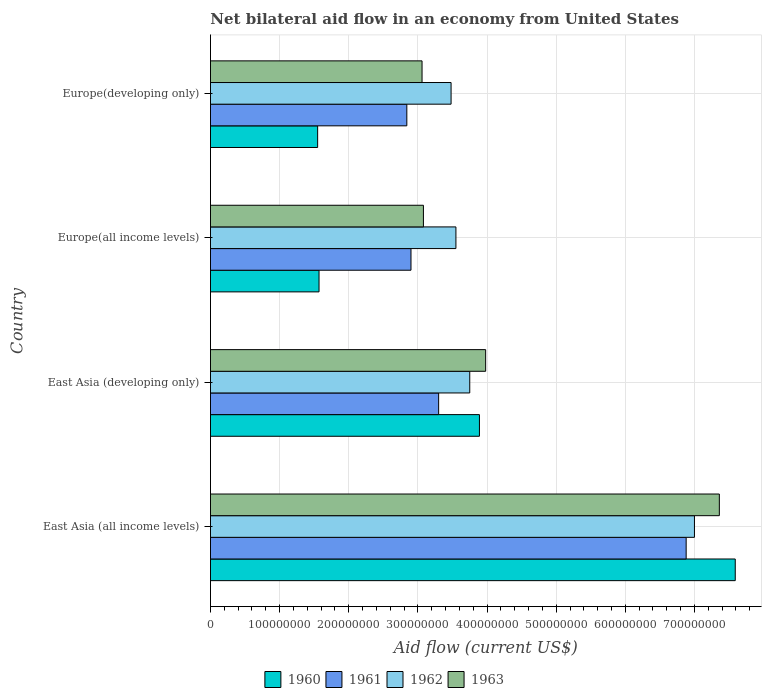How many different coloured bars are there?
Provide a short and direct response. 4. How many groups of bars are there?
Your answer should be compact. 4. Are the number of bars on each tick of the Y-axis equal?
Give a very brief answer. Yes. How many bars are there on the 3rd tick from the bottom?
Your answer should be compact. 4. What is the label of the 1st group of bars from the top?
Keep it short and to the point. Europe(developing only). What is the net bilateral aid flow in 1960 in East Asia (all income levels)?
Offer a very short reply. 7.59e+08. Across all countries, what is the maximum net bilateral aid flow in 1961?
Your answer should be compact. 6.88e+08. Across all countries, what is the minimum net bilateral aid flow in 1960?
Your answer should be compact. 1.55e+08. In which country was the net bilateral aid flow in 1960 maximum?
Your answer should be very brief. East Asia (all income levels). In which country was the net bilateral aid flow in 1963 minimum?
Your answer should be compact. Europe(developing only). What is the total net bilateral aid flow in 1963 in the graph?
Keep it short and to the point. 1.75e+09. What is the difference between the net bilateral aid flow in 1963 in Europe(developing only) and the net bilateral aid flow in 1962 in East Asia (developing only)?
Your answer should be compact. -6.90e+07. What is the average net bilateral aid flow in 1961 per country?
Provide a succinct answer. 3.98e+08. What is the difference between the net bilateral aid flow in 1963 and net bilateral aid flow in 1962 in East Asia (developing only)?
Provide a succinct answer. 2.30e+07. In how many countries, is the net bilateral aid flow in 1962 greater than 200000000 US$?
Your answer should be compact. 4. What is the ratio of the net bilateral aid flow in 1961 in East Asia (all income levels) to that in Europe(developing only)?
Give a very brief answer. 2.42. What is the difference between the highest and the second highest net bilateral aid flow in 1961?
Make the answer very short. 3.58e+08. What is the difference between the highest and the lowest net bilateral aid flow in 1963?
Offer a very short reply. 4.30e+08. In how many countries, is the net bilateral aid flow in 1961 greater than the average net bilateral aid flow in 1961 taken over all countries?
Provide a succinct answer. 1. How many bars are there?
Offer a terse response. 16. What is the difference between two consecutive major ticks on the X-axis?
Your answer should be compact. 1.00e+08. Are the values on the major ticks of X-axis written in scientific E-notation?
Offer a very short reply. No. Does the graph contain grids?
Give a very brief answer. Yes. What is the title of the graph?
Keep it short and to the point. Net bilateral aid flow in an economy from United States. What is the label or title of the X-axis?
Keep it short and to the point. Aid flow (current US$). What is the label or title of the Y-axis?
Your answer should be compact. Country. What is the Aid flow (current US$) of 1960 in East Asia (all income levels)?
Your answer should be very brief. 7.59e+08. What is the Aid flow (current US$) in 1961 in East Asia (all income levels)?
Keep it short and to the point. 6.88e+08. What is the Aid flow (current US$) of 1962 in East Asia (all income levels)?
Make the answer very short. 7.00e+08. What is the Aid flow (current US$) of 1963 in East Asia (all income levels)?
Your answer should be very brief. 7.36e+08. What is the Aid flow (current US$) of 1960 in East Asia (developing only)?
Your answer should be very brief. 3.89e+08. What is the Aid flow (current US$) of 1961 in East Asia (developing only)?
Ensure brevity in your answer.  3.30e+08. What is the Aid flow (current US$) in 1962 in East Asia (developing only)?
Provide a short and direct response. 3.75e+08. What is the Aid flow (current US$) in 1963 in East Asia (developing only)?
Give a very brief answer. 3.98e+08. What is the Aid flow (current US$) of 1960 in Europe(all income levels)?
Ensure brevity in your answer.  1.57e+08. What is the Aid flow (current US$) in 1961 in Europe(all income levels)?
Your answer should be very brief. 2.90e+08. What is the Aid flow (current US$) of 1962 in Europe(all income levels)?
Keep it short and to the point. 3.55e+08. What is the Aid flow (current US$) of 1963 in Europe(all income levels)?
Provide a succinct answer. 3.08e+08. What is the Aid flow (current US$) of 1960 in Europe(developing only)?
Offer a very short reply. 1.55e+08. What is the Aid flow (current US$) in 1961 in Europe(developing only)?
Your answer should be compact. 2.84e+08. What is the Aid flow (current US$) in 1962 in Europe(developing only)?
Offer a very short reply. 3.48e+08. What is the Aid flow (current US$) of 1963 in Europe(developing only)?
Offer a terse response. 3.06e+08. Across all countries, what is the maximum Aid flow (current US$) of 1960?
Your answer should be very brief. 7.59e+08. Across all countries, what is the maximum Aid flow (current US$) of 1961?
Make the answer very short. 6.88e+08. Across all countries, what is the maximum Aid flow (current US$) of 1962?
Offer a very short reply. 7.00e+08. Across all countries, what is the maximum Aid flow (current US$) of 1963?
Ensure brevity in your answer.  7.36e+08. Across all countries, what is the minimum Aid flow (current US$) of 1960?
Your response must be concise. 1.55e+08. Across all countries, what is the minimum Aid flow (current US$) in 1961?
Your answer should be very brief. 2.84e+08. Across all countries, what is the minimum Aid flow (current US$) in 1962?
Your response must be concise. 3.48e+08. Across all countries, what is the minimum Aid flow (current US$) of 1963?
Give a very brief answer. 3.06e+08. What is the total Aid flow (current US$) of 1960 in the graph?
Your response must be concise. 1.46e+09. What is the total Aid flow (current US$) in 1961 in the graph?
Provide a short and direct response. 1.59e+09. What is the total Aid flow (current US$) of 1962 in the graph?
Offer a very short reply. 1.78e+09. What is the total Aid flow (current US$) of 1963 in the graph?
Your answer should be compact. 1.75e+09. What is the difference between the Aid flow (current US$) of 1960 in East Asia (all income levels) and that in East Asia (developing only)?
Your response must be concise. 3.70e+08. What is the difference between the Aid flow (current US$) in 1961 in East Asia (all income levels) and that in East Asia (developing only)?
Ensure brevity in your answer.  3.58e+08. What is the difference between the Aid flow (current US$) in 1962 in East Asia (all income levels) and that in East Asia (developing only)?
Offer a very short reply. 3.25e+08. What is the difference between the Aid flow (current US$) in 1963 in East Asia (all income levels) and that in East Asia (developing only)?
Offer a very short reply. 3.38e+08. What is the difference between the Aid flow (current US$) in 1960 in East Asia (all income levels) and that in Europe(all income levels)?
Provide a succinct answer. 6.02e+08. What is the difference between the Aid flow (current US$) of 1961 in East Asia (all income levels) and that in Europe(all income levels)?
Give a very brief answer. 3.98e+08. What is the difference between the Aid flow (current US$) in 1962 in East Asia (all income levels) and that in Europe(all income levels)?
Your answer should be very brief. 3.45e+08. What is the difference between the Aid flow (current US$) of 1963 in East Asia (all income levels) and that in Europe(all income levels)?
Give a very brief answer. 4.28e+08. What is the difference between the Aid flow (current US$) in 1960 in East Asia (all income levels) and that in Europe(developing only)?
Offer a terse response. 6.04e+08. What is the difference between the Aid flow (current US$) of 1961 in East Asia (all income levels) and that in Europe(developing only)?
Make the answer very short. 4.04e+08. What is the difference between the Aid flow (current US$) of 1962 in East Asia (all income levels) and that in Europe(developing only)?
Your answer should be compact. 3.52e+08. What is the difference between the Aid flow (current US$) in 1963 in East Asia (all income levels) and that in Europe(developing only)?
Give a very brief answer. 4.30e+08. What is the difference between the Aid flow (current US$) in 1960 in East Asia (developing only) and that in Europe(all income levels)?
Keep it short and to the point. 2.32e+08. What is the difference between the Aid flow (current US$) in 1961 in East Asia (developing only) and that in Europe(all income levels)?
Offer a terse response. 4.00e+07. What is the difference between the Aid flow (current US$) in 1962 in East Asia (developing only) and that in Europe(all income levels)?
Provide a short and direct response. 2.00e+07. What is the difference between the Aid flow (current US$) in 1963 in East Asia (developing only) and that in Europe(all income levels)?
Keep it short and to the point. 9.00e+07. What is the difference between the Aid flow (current US$) of 1960 in East Asia (developing only) and that in Europe(developing only)?
Provide a short and direct response. 2.34e+08. What is the difference between the Aid flow (current US$) in 1961 in East Asia (developing only) and that in Europe(developing only)?
Your answer should be very brief. 4.60e+07. What is the difference between the Aid flow (current US$) of 1962 in East Asia (developing only) and that in Europe(developing only)?
Give a very brief answer. 2.70e+07. What is the difference between the Aid flow (current US$) in 1963 in East Asia (developing only) and that in Europe(developing only)?
Give a very brief answer. 9.20e+07. What is the difference between the Aid flow (current US$) of 1961 in Europe(all income levels) and that in Europe(developing only)?
Your answer should be very brief. 6.00e+06. What is the difference between the Aid flow (current US$) in 1962 in Europe(all income levels) and that in Europe(developing only)?
Make the answer very short. 7.00e+06. What is the difference between the Aid flow (current US$) in 1960 in East Asia (all income levels) and the Aid flow (current US$) in 1961 in East Asia (developing only)?
Ensure brevity in your answer.  4.29e+08. What is the difference between the Aid flow (current US$) of 1960 in East Asia (all income levels) and the Aid flow (current US$) of 1962 in East Asia (developing only)?
Keep it short and to the point. 3.84e+08. What is the difference between the Aid flow (current US$) in 1960 in East Asia (all income levels) and the Aid flow (current US$) in 1963 in East Asia (developing only)?
Your answer should be compact. 3.61e+08. What is the difference between the Aid flow (current US$) of 1961 in East Asia (all income levels) and the Aid flow (current US$) of 1962 in East Asia (developing only)?
Make the answer very short. 3.13e+08. What is the difference between the Aid flow (current US$) in 1961 in East Asia (all income levels) and the Aid flow (current US$) in 1963 in East Asia (developing only)?
Offer a very short reply. 2.90e+08. What is the difference between the Aid flow (current US$) in 1962 in East Asia (all income levels) and the Aid flow (current US$) in 1963 in East Asia (developing only)?
Ensure brevity in your answer.  3.02e+08. What is the difference between the Aid flow (current US$) of 1960 in East Asia (all income levels) and the Aid flow (current US$) of 1961 in Europe(all income levels)?
Offer a very short reply. 4.69e+08. What is the difference between the Aid flow (current US$) in 1960 in East Asia (all income levels) and the Aid flow (current US$) in 1962 in Europe(all income levels)?
Offer a terse response. 4.04e+08. What is the difference between the Aid flow (current US$) in 1960 in East Asia (all income levels) and the Aid flow (current US$) in 1963 in Europe(all income levels)?
Give a very brief answer. 4.51e+08. What is the difference between the Aid flow (current US$) of 1961 in East Asia (all income levels) and the Aid flow (current US$) of 1962 in Europe(all income levels)?
Provide a succinct answer. 3.33e+08. What is the difference between the Aid flow (current US$) of 1961 in East Asia (all income levels) and the Aid flow (current US$) of 1963 in Europe(all income levels)?
Give a very brief answer. 3.80e+08. What is the difference between the Aid flow (current US$) of 1962 in East Asia (all income levels) and the Aid flow (current US$) of 1963 in Europe(all income levels)?
Offer a terse response. 3.92e+08. What is the difference between the Aid flow (current US$) of 1960 in East Asia (all income levels) and the Aid flow (current US$) of 1961 in Europe(developing only)?
Make the answer very short. 4.75e+08. What is the difference between the Aid flow (current US$) of 1960 in East Asia (all income levels) and the Aid flow (current US$) of 1962 in Europe(developing only)?
Give a very brief answer. 4.11e+08. What is the difference between the Aid flow (current US$) in 1960 in East Asia (all income levels) and the Aid flow (current US$) in 1963 in Europe(developing only)?
Your answer should be compact. 4.53e+08. What is the difference between the Aid flow (current US$) of 1961 in East Asia (all income levels) and the Aid flow (current US$) of 1962 in Europe(developing only)?
Keep it short and to the point. 3.40e+08. What is the difference between the Aid flow (current US$) of 1961 in East Asia (all income levels) and the Aid flow (current US$) of 1963 in Europe(developing only)?
Make the answer very short. 3.82e+08. What is the difference between the Aid flow (current US$) in 1962 in East Asia (all income levels) and the Aid flow (current US$) in 1963 in Europe(developing only)?
Your answer should be very brief. 3.94e+08. What is the difference between the Aid flow (current US$) in 1960 in East Asia (developing only) and the Aid flow (current US$) in 1961 in Europe(all income levels)?
Your response must be concise. 9.90e+07. What is the difference between the Aid flow (current US$) in 1960 in East Asia (developing only) and the Aid flow (current US$) in 1962 in Europe(all income levels)?
Offer a very short reply. 3.40e+07. What is the difference between the Aid flow (current US$) of 1960 in East Asia (developing only) and the Aid flow (current US$) of 1963 in Europe(all income levels)?
Give a very brief answer. 8.10e+07. What is the difference between the Aid flow (current US$) of 1961 in East Asia (developing only) and the Aid flow (current US$) of 1962 in Europe(all income levels)?
Your answer should be very brief. -2.50e+07. What is the difference between the Aid flow (current US$) of 1961 in East Asia (developing only) and the Aid flow (current US$) of 1963 in Europe(all income levels)?
Your answer should be compact. 2.20e+07. What is the difference between the Aid flow (current US$) of 1962 in East Asia (developing only) and the Aid flow (current US$) of 1963 in Europe(all income levels)?
Make the answer very short. 6.70e+07. What is the difference between the Aid flow (current US$) of 1960 in East Asia (developing only) and the Aid flow (current US$) of 1961 in Europe(developing only)?
Your response must be concise. 1.05e+08. What is the difference between the Aid flow (current US$) in 1960 in East Asia (developing only) and the Aid flow (current US$) in 1962 in Europe(developing only)?
Keep it short and to the point. 4.10e+07. What is the difference between the Aid flow (current US$) in 1960 in East Asia (developing only) and the Aid flow (current US$) in 1963 in Europe(developing only)?
Offer a terse response. 8.30e+07. What is the difference between the Aid flow (current US$) of 1961 in East Asia (developing only) and the Aid flow (current US$) of 1962 in Europe(developing only)?
Ensure brevity in your answer.  -1.80e+07. What is the difference between the Aid flow (current US$) of 1961 in East Asia (developing only) and the Aid flow (current US$) of 1963 in Europe(developing only)?
Give a very brief answer. 2.40e+07. What is the difference between the Aid flow (current US$) in 1962 in East Asia (developing only) and the Aid flow (current US$) in 1963 in Europe(developing only)?
Your answer should be compact. 6.90e+07. What is the difference between the Aid flow (current US$) of 1960 in Europe(all income levels) and the Aid flow (current US$) of 1961 in Europe(developing only)?
Your answer should be very brief. -1.27e+08. What is the difference between the Aid flow (current US$) in 1960 in Europe(all income levels) and the Aid flow (current US$) in 1962 in Europe(developing only)?
Provide a succinct answer. -1.91e+08. What is the difference between the Aid flow (current US$) in 1960 in Europe(all income levels) and the Aid flow (current US$) in 1963 in Europe(developing only)?
Make the answer very short. -1.49e+08. What is the difference between the Aid flow (current US$) of 1961 in Europe(all income levels) and the Aid flow (current US$) of 1962 in Europe(developing only)?
Provide a short and direct response. -5.80e+07. What is the difference between the Aid flow (current US$) in 1961 in Europe(all income levels) and the Aid flow (current US$) in 1963 in Europe(developing only)?
Provide a succinct answer. -1.60e+07. What is the difference between the Aid flow (current US$) in 1962 in Europe(all income levels) and the Aid flow (current US$) in 1963 in Europe(developing only)?
Your answer should be very brief. 4.90e+07. What is the average Aid flow (current US$) of 1960 per country?
Ensure brevity in your answer.  3.65e+08. What is the average Aid flow (current US$) of 1961 per country?
Provide a short and direct response. 3.98e+08. What is the average Aid flow (current US$) of 1962 per country?
Keep it short and to the point. 4.44e+08. What is the average Aid flow (current US$) of 1963 per country?
Make the answer very short. 4.37e+08. What is the difference between the Aid flow (current US$) in 1960 and Aid flow (current US$) in 1961 in East Asia (all income levels)?
Make the answer very short. 7.10e+07. What is the difference between the Aid flow (current US$) in 1960 and Aid flow (current US$) in 1962 in East Asia (all income levels)?
Provide a short and direct response. 5.90e+07. What is the difference between the Aid flow (current US$) of 1960 and Aid flow (current US$) of 1963 in East Asia (all income levels)?
Make the answer very short. 2.30e+07. What is the difference between the Aid flow (current US$) in 1961 and Aid flow (current US$) in 1962 in East Asia (all income levels)?
Offer a terse response. -1.20e+07. What is the difference between the Aid flow (current US$) of 1961 and Aid flow (current US$) of 1963 in East Asia (all income levels)?
Your answer should be compact. -4.80e+07. What is the difference between the Aid flow (current US$) in 1962 and Aid flow (current US$) in 1963 in East Asia (all income levels)?
Your answer should be very brief. -3.60e+07. What is the difference between the Aid flow (current US$) in 1960 and Aid flow (current US$) in 1961 in East Asia (developing only)?
Give a very brief answer. 5.90e+07. What is the difference between the Aid flow (current US$) in 1960 and Aid flow (current US$) in 1962 in East Asia (developing only)?
Make the answer very short. 1.40e+07. What is the difference between the Aid flow (current US$) in 1960 and Aid flow (current US$) in 1963 in East Asia (developing only)?
Keep it short and to the point. -9.00e+06. What is the difference between the Aid flow (current US$) of 1961 and Aid flow (current US$) of 1962 in East Asia (developing only)?
Ensure brevity in your answer.  -4.50e+07. What is the difference between the Aid flow (current US$) in 1961 and Aid flow (current US$) in 1963 in East Asia (developing only)?
Your response must be concise. -6.80e+07. What is the difference between the Aid flow (current US$) of 1962 and Aid flow (current US$) of 1963 in East Asia (developing only)?
Your response must be concise. -2.30e+07. What is the difference between the Aid flow (current US$) in 1960 and Aid flow (current US$) in 1961 in Europe(all income levels)?
Offer a very short reply. -1.33e+08. What is the difference between the Aid flow (current US$) in 1960 and Aid flow (current US$) in 1962 in Europe(all income levels)?
Provide a short and direct response. -1.98e+08. What is the difference between the Aid flow (current US$) in 1960 and Aid flow (current US$) in 1963 in Europe(all income levels)?
Make the answer very short. -1.51e+08. What is the difference between the Aid flow (current US$) of 1961 and Aid flow (current US$) of 1962 in Europe(all income levels)?
Offer a very short reply. -6.50e+07. What is the difference between the Aid flow (current US$) in 1961 and Aid flow (current US$) in 1963 in Europe(all income levels)?
Ensure brevity in your answer.  -1.80e+07. What is the difference between the Aid flow (current US$) in 1962 and Aid flow (current US$) in 1963 in Europe(all income levels)?
Provide a succinct answer. 4.70e+07. What is the difference between the Aid flow (current US$) of 1960 and Aid flow (current US$) of 1961 in Europe(developing only)?
Keep it short and to the point. -1.29e+08. What is the difference between the Aid flow (current US$) in 1960 and Aid flow (current US$) in 1962 in Europe(developing only)?
Offer a very short reply. -1.93e+08. What is the difference between the Aid flow (current US$) in 1960 and Aid flow (current US$) in 1963 in Europe(developing only)?
Keep it short and to the point. -1.51e+08. What is the difference between the Aid flow (current US$) in 1961 and Aid flow (current US$) in 1962 in Europe(developing only)?
Provide a succinct answer. -6.40e+07. What is the difference between the Aid flow (current US$) in 1961 and Aid flow (current US$) in 1963 in Europe(developing only)?
Make the answer very short. -2.20e+07. What is the difference between the Aid flow (current US$) of 1962 and Aid flow (current US$) of 1963 in Europe(developing only)?
Offer a very short reply. 4.20e+07. What is the ratio of the Aid flow (current US$) in 1960 in East Asia (all income levels) to that in East Asia (developing only)?
Offer a terse response. 1.95. What is the ratio of the Aid flow (current US$) in 1961 in East Asia (all income levels) to that in East Asia (developing only)?
Your response must be concise. 2.08. What is the ratio of the Aid flow (current US$) of 1962 in East Asia (all income levels) to that in East Asia (developing only)?
Offer a very short reply. 1.87. What is the ratio of the Aid flow (current US$) in 1963 in East Asia (all income levels) to that in East Asia (developing only)?
Offer a terse response. 1.85. What is the ratio of the Aid flow (current US$) of 1960 in East Asia (all income levels) to that in Europe(all income levels)?
Offer a terse response. 4.83. What is the ratio of the Aid flow (current US$) of 1961 in East Asia (all income levels) to that in Europe(all income levels)?
Your response must be concise. 2.37. What is the ratio of the Aid flow (current US$) of 1962 in East Asia (all income levels) to that in Europe(all income levels)?
Provide a short and direct response. 1.97. What is the ratio of the Aid flow (current US$) of 1963 in East Asia (all income levels) to that in Europe(all income levels)?
Ensure brevity in your answer.  2.39. What is the ratio of the Aid flow (current US$) of 1960 in East Asia (all income levels) to that in Europe(developing only)?
Keep it short and to the point. 4.9. What is the ratio of the Aid flow (current US$) of 1961 in East Asia (all income levels) to that in Europe(developing only)?
Your answer should be very brief. 2.42. What is the ratio of the Aid flow (current US$) in 1962 in East Asia (all income levels) to that in Europe(developing only)?
Ensure brevity in your answer.  2.01. What is the ratio of the Aid flow (current US$) of 1963 in East Asia (all income levels) to that in Europe(developing only)?
Make the answer very short. 2.41. What is the ratio of the Aid flow (current US$) in 1960 in East Asia (developing only) to that in Europe(all income levels)?
Make the answer very short. 2.48. What is the ratio of the Aid flow (current US$) of 1961 in East Asia (developing only) to that in Europe(all income levels)?
Offer a terse response. 1.14. What is the ratio of the Aid flow (current US$) of 1962 in East Asia (developing only) to that in Europe(all income levels)?
Offer a very short reply. 1.06. What is the ratio of the Aid flow (current US$) of 1963 in East Asia (developing only) to that in Europe(all income levels)?
Offer a terse response. 1.29. What is the ratio of the Aid flow (current US$) of 1960 in East Asia (developing only) to that in Europe(developing only)?
Give a very brief answer. 2.51. What is the ratio of the Aid flow (current US$) in 1961 in East Asia (developing only) to that in Europe(developing only)?
Provide a succinct answer. 1.16. What is the ratio of the Aid flow (current US$) in 1962 in East Asia (developing only) to that in Europe(developing only)?
Provide a short and direct response. 1.08. What is the ratio of the Aid flow (current US$) of 1963 in East Asia (developing only) to that in Europe(developing only)?
Your response must be concise. 1.3. What is the ratio of the Aid flow (current US$) in 1960 in Europe(all income levels) to that in Europe(developing only)?
Offer a very short reply. 1.01. What is the ratio of the Aid flow (current US$) of 1961 in Europe(all income levels) to that in Europe(developing only)?
Your response must be concise. 1.02. What is the ratio of the Aid flow (current US$) of 1962 in Europe(all income levels) to that in Europe(developing only)?
Offer a very short reply. 1.02. What is the ratio of the Aid flow (current US$) in 1963 in Europe(all income levels) to that in Europe(developing only)?
Offer a terse response. 1.01. What is the difference between the highest and the second highest Aid flow (current US$) in 1960?
Your answer should be very brief. 3.70e+08. What is the difference between the highest and the second highest Aid flow (current US$) of 1961?
Provide a succinct answer. 3.58e+08. What is the difference between the highest and the second highest Aid flow (current US$) in 1962?
Your response must be concise. 3.25e+08. What is the difference between the highest and the second highest Aid flow (current US$) in 1963?
Keep it short and to the point. 3.38e+08. What is the difference between the highest and the lowest Aid flow (current US$) of 1960?
Give a very brief answer. 6.04e+08. What is the difference between the highest and the lowest Aid flow (current US$) of 1961?
Your answer should be compact. 4.04e+08. What is the difference between the highest and the lowest Aid flow (current US$) in 1962?
Keep it short and to the point. 3.52e+08. What is the difference between the highest and the lowest Aid flow (current US$) of 1963?
Your answer should be very brief. 4.30e+08. 